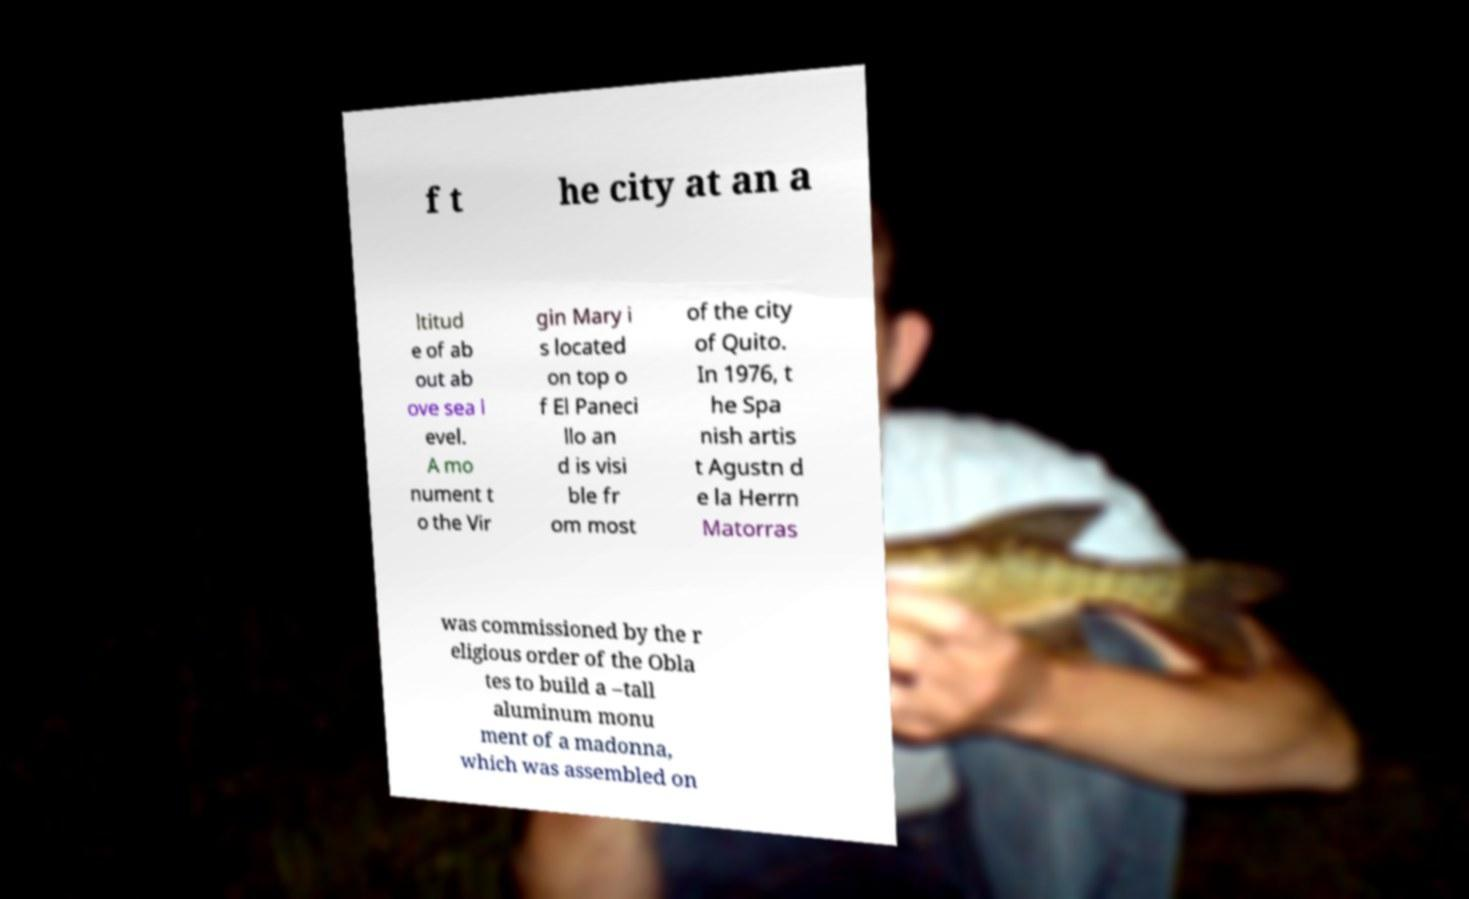Could you assist in decoding the text presented in this image and type it out clearly? f t he city at an a ltitud e of ab out ab ove sea l evel. A mo nument t o the Vir gin Mary i s located on top o f El Paneci llo an d is visi ble fr om most of the city of Quito. In 1976, t he Spa nish artis t Agustn d e la Herrn Matorras was commissioned by the r eligious order of the Obla tes to build a –tall aluminum monu ment of a madonna, which was assembled on 